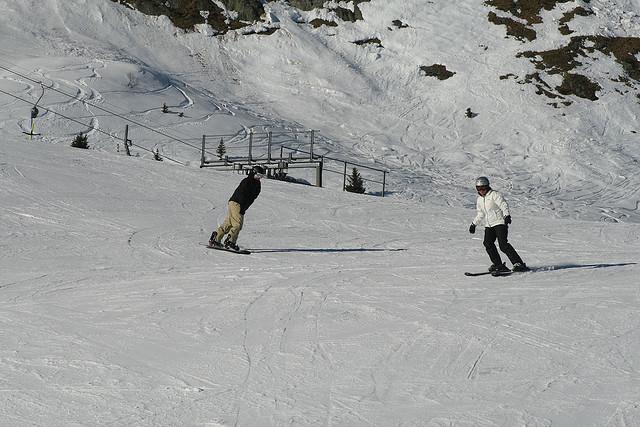How do you know other snowboarders have been down the mountain already?
Concise answer only. Tracks. Are all of the people currently skiing?
Give a very brief answer. Yes. What is the metal object to the very left?
Answer briefly. Ski lift. How many trees are there?
Short answer required. 3. What color outfit is this man wearing?
Concise answer only. White. What is covering the ground?
Write a very short answer. Snow. How many people are there?
Short answer required. 2. How many people are shown?
Keep it brief. 2. 